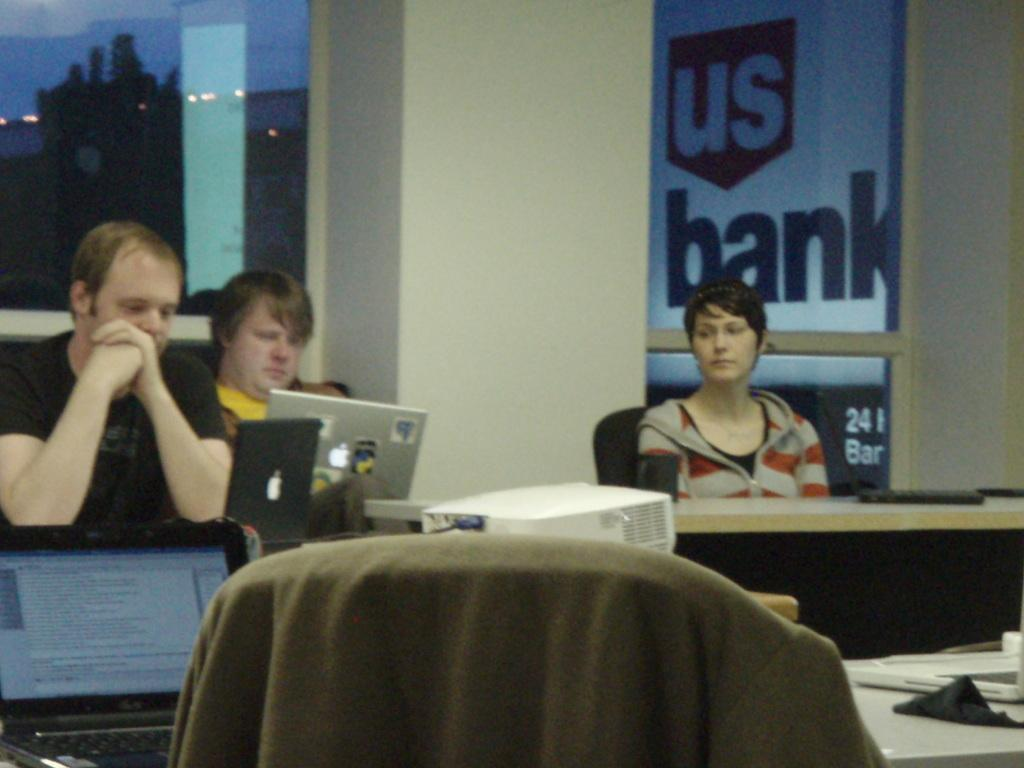How many people are present in the image? There are three people in the image. What is the woman doing in the image? The woman is sitting on a chair. What can be seen on the table in the image? There is a laptop or projector on a table. What is visible in the background of the image? There is a board named "Us Bank" in the background, as well as a tree and the sky. What type of flower is growing on the woman's head in the image? There is no flower present on the woman's head in the image. What is the sun doing in the image? The sun is not an object or element present in the image; it is a celestial body that provides light and heat. 